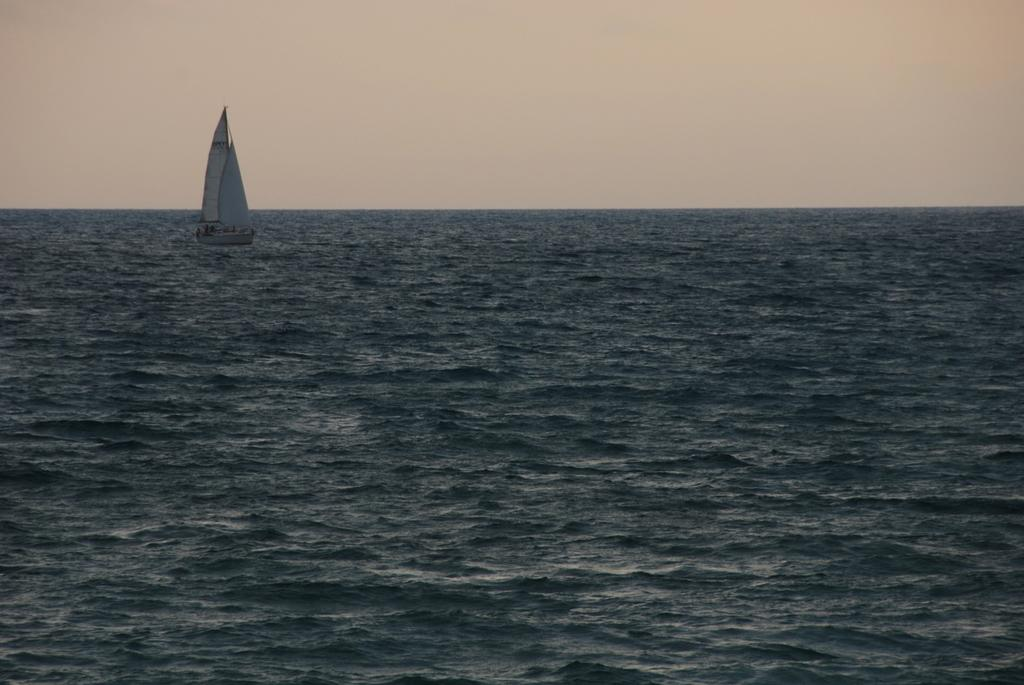What is the main subject of the image? The main subject of the image is a boat. Where is the boat located? The boat is in the water. What type of destruction can be seen caused by the snake in the image? There is no snake present in the image, and therefore no destruction can be observed. How does the pollution affect the boat in the image? There is no mention of pollution in the image, so its effect on the boat cannot be determined. 